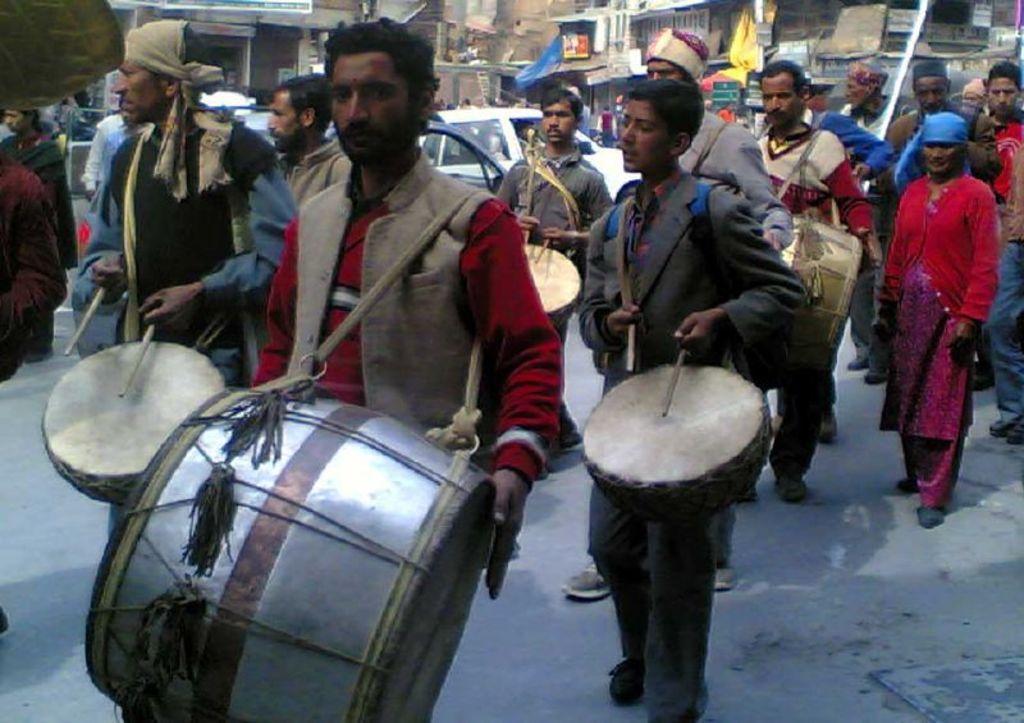Describe this image in one or two sentences. In this picture we can see some people standing, few persons in the front are playing drums, in the background there is a building, we can see cars in the middle, we can also see a cover in the background. 